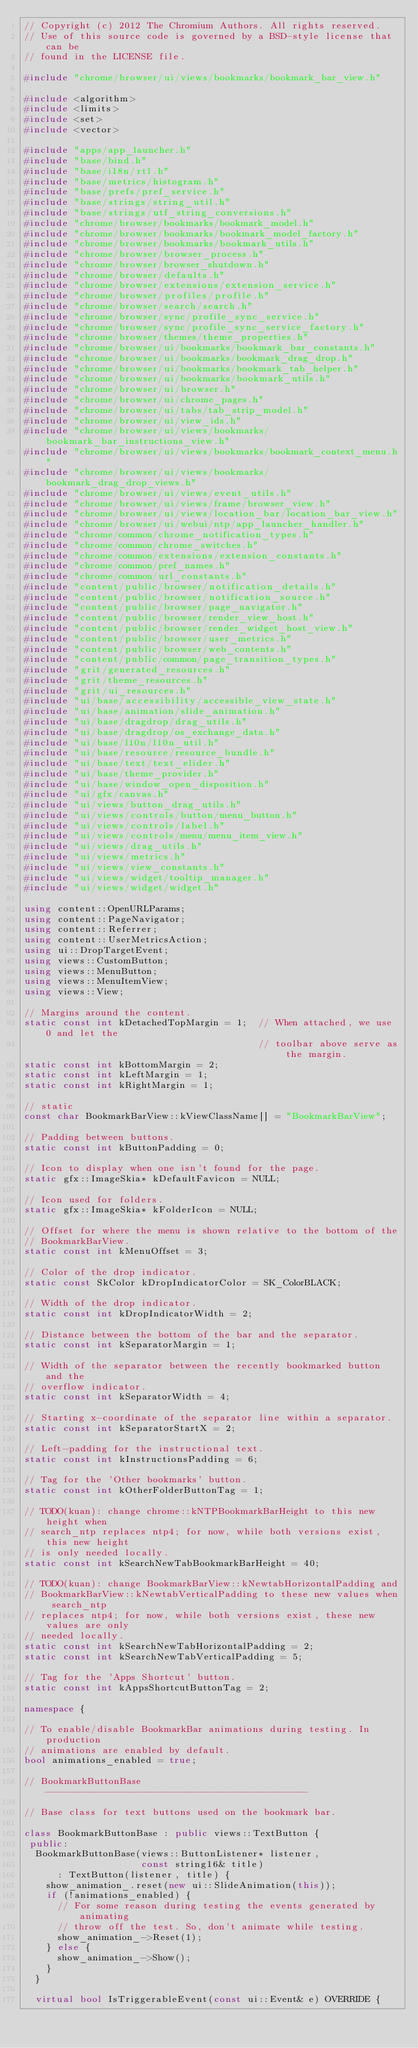<code> <loc_0><loc_0><loc_500><loc_500><_C++_>// Copyright (c) 2012 The Chromium Authors. All rights reserved.
// Use of this source code is governed by a BSD-style license that can be
// found in the LICENSE file.

#include "chrome/browser/ui/views/bookmarks/bookmark_bar_view.h"

#include <algorithm>
#include <limits>
#include <set>
#include <vector>

#include "apps/app_launcher.h"
#include "base/bind.h"
#include "base/i18n/rtl.h"
#include "base/metrics/histogram.h"
#include "base/prefs/pref_service.h"
#include "base/strings/string_util.h"
#include "base/strings/utf_string_conversions.h"
#include "chrome/browser/bookmarks/bookmark_model.h"
#include "chrome/browser/bookmarks/bookmark_model_factory.h"
#include "chrome/browser/bookmarks/bookmark_utils.h"
#include "chrome/browser/browser_process.h"
#include "chrome/browser/browser_shutdown.h"
#include "chrome/browser/defaults.h"
#include "chrome/browser/extensions/extension_service.h"
#include "chrome/browser/profiles/profile.h"
#include "chrome/browser/search/search.h"
#include "chrome/browser/sync/profile_sync_service.h"
#include "chrome/browser/sync/profile_sync_service_factory.h"
#include "chrome/browser/themes/theme_properties.h"
#include "chrome/browser/ui/bookmarks/bookmark_bar_constants.h"
#include "chrome/browser/ui/bookmarks/bookmark_drag_drop.h"
#include "chrome/browser/ui/bookmarks/bookmark_tab_helper.h"
#include "chrome/browser/ui/bookmarks/bookmark_utils.h"
#include "chrome/browser/ui/browser.h"
#include "chrome/browser/ui/chrome_pages.h"
#include "chrome/browser/ui/tabs/tab_strip_model.h"
#include "chrome/browser/ui/view_ids.h"
#include "chrome/browser/ui/views/bookmarks/bookmark_bar_instructions_view.h"
#include "chrome/browser/ui/views/bookmarks/bookmark_context_menu.h"
#include "chrome/browser/ui/views/bookmarks/bookmark_drag_drop_views.h"
#include "chrome/browser/ui/views/event_utils.h"
#include "chrome/browser/ui/views/frame/browser_view.h"
#include "chrome/browser/ui/views/location_bar/location_bar_view.h"
#include "chrome/browser/ui/webui/ntp/app_launcher_handler.h"
#include "chrome/common/chrome_notification_types.h"
#include "chrome/common/chrome_switches.h"
#include "chrome/common/extensions/extension_constants.h"
#include "chrome/common/pref_names.h"
#include "chrome/common/url_constants.h"
#include "content/public/browser/notification_details.h"
#include "content/public/browser/notification_source.h"
#include "content/public/browser/page_navigator.h"
#include "content/public/browser/render_view_host.h"
#include "content/public/browser/render_widget_host_view.h"
#include "content/public/browser/user_metrics.h"
#include "content/public/browser/web_contents.h"
#include "content/public/common/page_transition_types.h"
#include "grit/generated_resources.h"
#include "grit/theme_resources.h"
#include "grit/ui_resources.h"
#include "ui/base/accessibility/accessible_view_state.h"
#include "ui/base/animation/slide_animation.h"
#include "ui/base/dragdrop/drag_utils.h"
#include "ui/base/dragdrop/os_exchange_data.h"
#include "ui/base/l10n/l10n_util.h"
#include "ui/base/resource/resource_bundle.h"
#include "ui/base/text/text_elider.h"
#include "ui/base/theme_provider.h"
#include "ui/base/window_open_disposition.h"
#include "ui/gfx/canvas.h"
#include "ui/views/button_drag_utils.h"
#include "ui/views/controls/button/menu_button.h"
#include "ui/views/controls/label.h"
#include "ui/views/controls/menu/menu_item_view.h"
#include "ui/views/drag_utils.h"
#include "ui/views/metrics.h"
#include "ui/views/view_constants.h"
#include "ui/views/widget/tooltip_manager.h"
#include "ui/views/widget/widget.h"

using content::OpenURLParams;
using content::PageNavigator;
using content::Referrer;
using content::UserMetricsAction;
using ui::DropTargetEvent;
using views::CustomButton;
using views::MenuButton;
using views::MenuItemView;
using views::View;

// Margins around the content.
static const int kDetachedTopMargin = 1;  // When attached, we use 0 and let the
                                          // toolbar above serve as the margin.
static const int kBottomMargin = 2;
static const int kLeftMargin = 1;
static const int kRightMargin = 1;

// static
const char BookmarkBarView::kViewClassName[] = "BookmarkBarView";

// Padding between buttons.
static const int kButtonPadding = 0;

// Icon to display when one isn't found for the page.
static gfx::ImageSkia* kDefaultFavicon = NULL;

// Icon used for folders.
static gfx::ImageSkia* kFolderIcon = NULL;

// Offset for where the menu is shown relative to the bottom of the
// BookmarkBarView.
static const int kMenuOffset = 3;

// Color of the drop indicator.
static const SkColor kDropIndicatorColor = SK_ColorBLACK;

// Width of the drop indicator.
static const int kDropIndicatorWidth = 2;

// Distance between the bottom of the bar and the separator.
static const int kSeparatorMargin = 1;

// Width of the separator between the recently bookmarked button and the
// overflow indicator.
static const int kSeparatorWidth = 4;

// Starting x-coordinate of the separator line within a separator.
static const int kSeparatorStartX = 2;

// Left-padding for the instructional text.
static const int kInstructionsPadding = 6;

// Tag for the 'Other bookmarks' button.
static const int kOtherFolderButtonTag = 1;

// TODO(kuan): change chrome::kNTPBookmarkBarHeight to this new height when
// search_ntp replaces ntp4; for now, while both versions exist, this new height
// is only needed locally.
static const int kSearchNewTabBookmarkBarHeight = 40;

// TODO(kuan): change BookmarkBarView::kNewtabHorizontalPadding and
// BookmarkBarView::kNewtabVerticalPadding to these new values when search_ntp
// replaces ntp4; for now, while both versions exist, these new values are only
// needed locally.
static const int kSearchNewTabHorizontalPadding = 2;
static const int kSearchNewTabVerticalPadding = 5;

// Tag for the 'Apps Shortcut' button.
static const int kAppsShortcutButtonTag = 2;

namespace {

// To enable/disable BookmarkBar animations during testing. In production
// animations are enabled by default.
bool animations_enabled = true;

// BookmarkButtonBase -----------------------------------------------

// Base class for text buttons used on the bookmark bar.

class BookmarkButtonBase : public views::TextButton {
 public:
  BookmarkButtonBase(views::ButtonListener* listener,
                     const string16& title)
      : TextButton(listener, title) {
    show_animation_.reset(new ui::SlideAnimation(this));
    if (!animations_enabled) {
      // For some reason during testing the events generated by animating
      // throw off the test. So, don't animate while testing.
      show_animation_->Reset(1);
    } else {
      show_animation_->Show();
    }
  }

  virtual bool IsTriggerableEvent(const ui::Event& e) OVERRIDE {</code> 